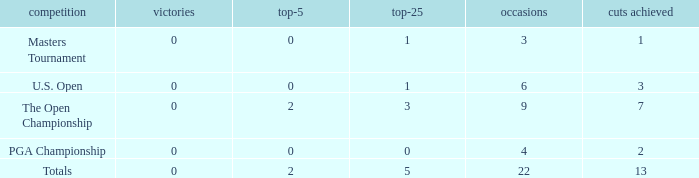What is the fewest number of top-25s for events with more than 13 cuts made? None. Could you parse the entire table? {'header': ['competition', 'victories', 'top-5', 'top-25', 'occasions', 'cuts achieved'], 'rows': [['Masters Tournament', '0', '0', '1', '3', '1'], ['U.S. Open', '0', '0', '1', '6', '3'], ['The Open Championship', '0', '2', '3', '9', '7'], ['PGA Championship', '0', '0', '0', '4', '2'], ['Totals', '0', '2', '5', '22', '13']]} 